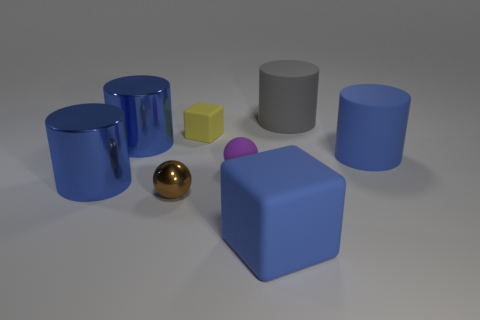There is a tiny purple matte thing; are there any small matte objects left of it?
Provide a short and direct response. Yes. Are there more big yellow things than small objects?
Your answer should be very brief. No. The big thing behind the big blue cylinder behind the thing to the right of the big gray object is what color?
Your answer should be compact. Gray. What is the color of the small block that is the same material as the large blue block?
Make the answer very short. Yellow. How many things are big gray rubber objects to the right of the metal sphere or tiny matte things that are left of the big gray matte thing?
Make the answer very short. 3. Does the ball right of the brown metallic ball have the same size as the thing behind the small yellow rubber block?
Ensure brevity in your answer.  No. There is another matte object that is the same shape as the yellow matte thing; what is its color?
Make the answer very short. Blue. Are there more large rubber things left of the large gray object than big cubes that are on the left side of the brown metal ball?
Ensure brevity in your answer.  Yes. What size is the cylinder that is in front of the tiny ball that is behind the large metal cylinder in front of the large blue rubber cylinder?
Your answer should be very brief. Large. Are the purple object and the gray object that is right of the tiny yellow matte object made of the same material?
Offer a very short reply. Yes. 